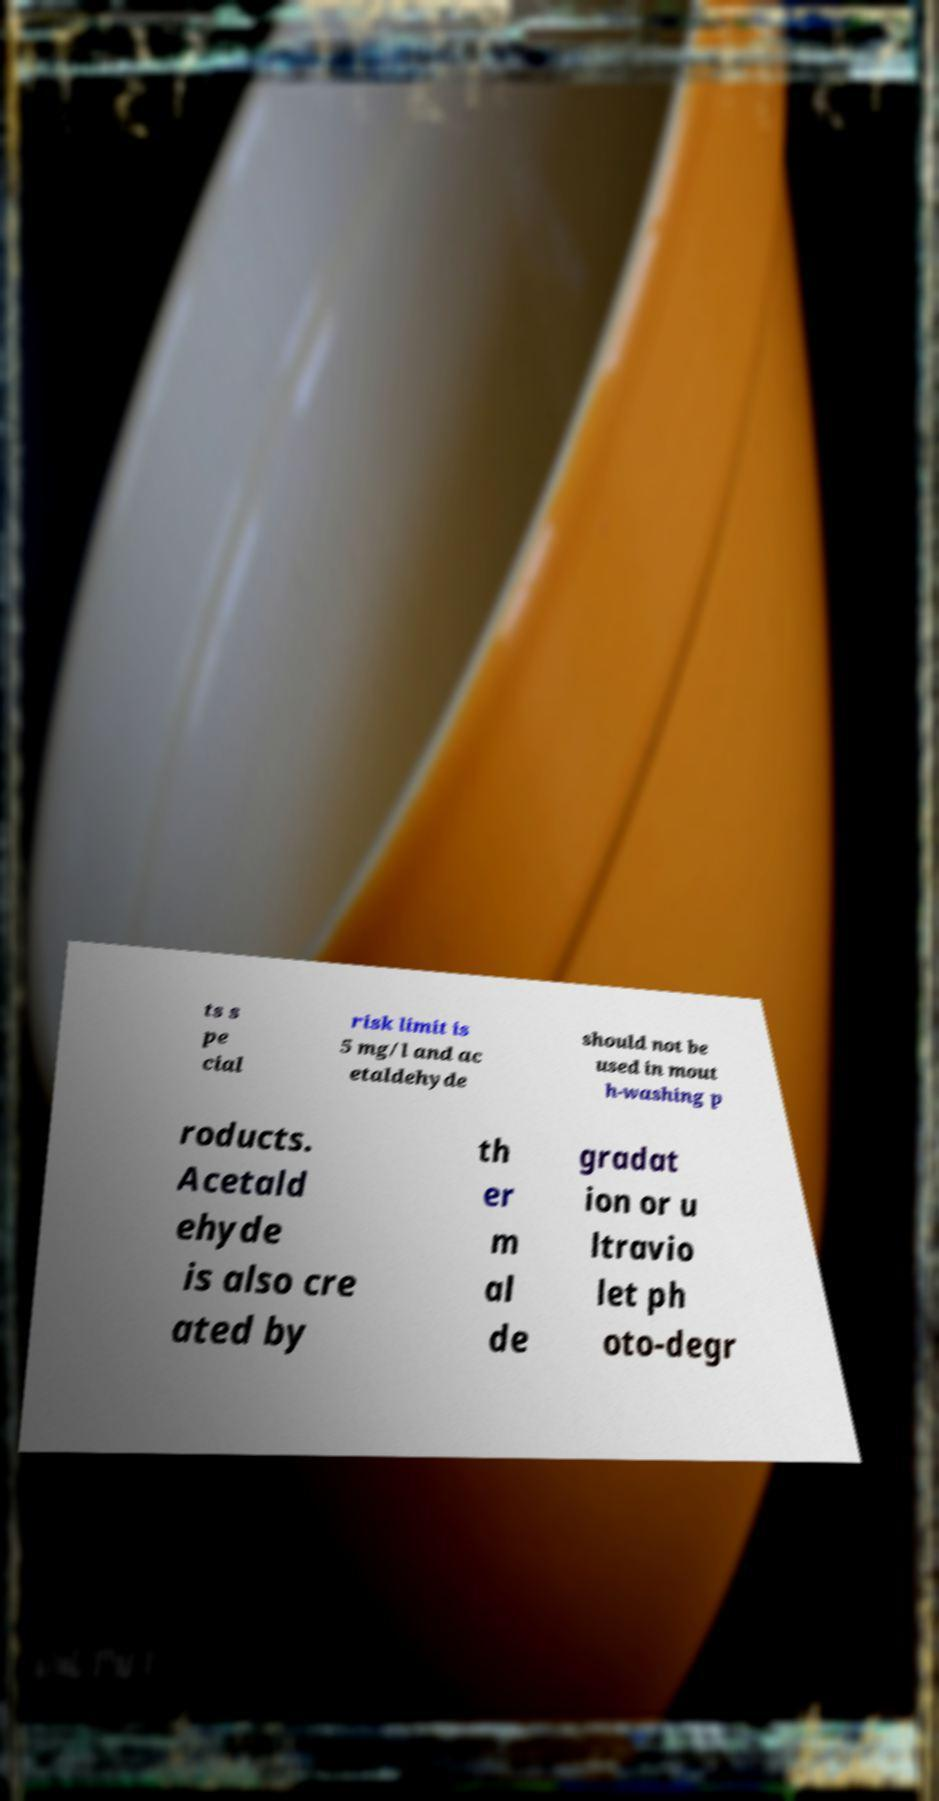Please identify and transcribe the text found in this image. ts s pe cial risk limit is 5 mg/l and ac etaldehyde should not be used in mout h-washing p roducts. Acetald ehyde is also cre ated by th er m al de gradat ion or u ltravio let ph oto-degr 